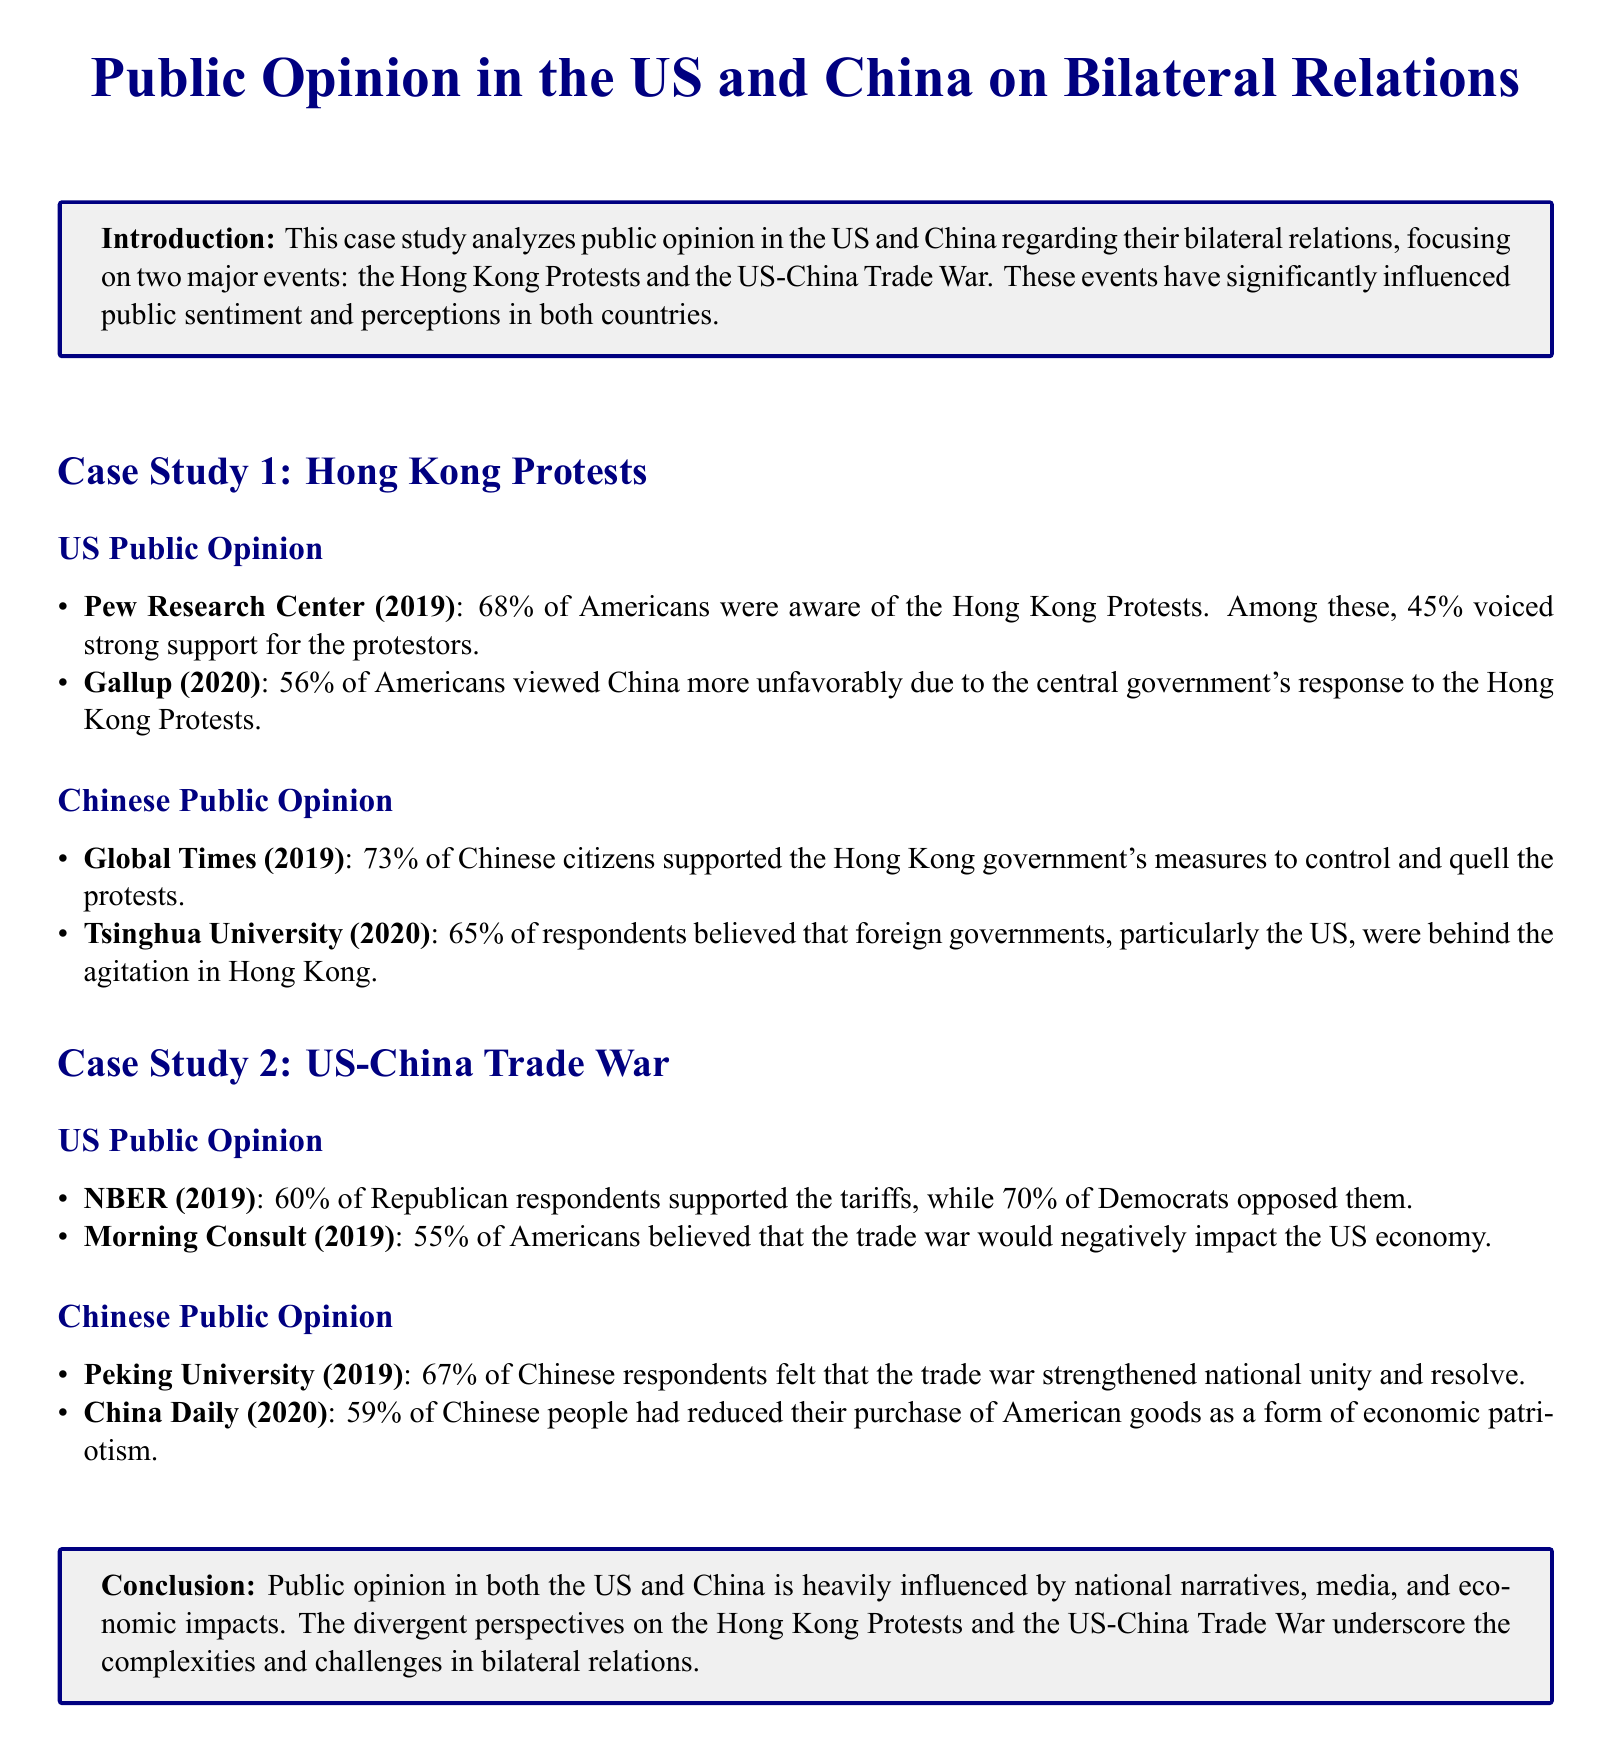What percentage of Americans were aware of the Hong Kong Protests? The document states that 68% of Americans were aware of the Hong Kong Protests according to Pew Research Center.
Answer: 68% What was the strong support percentage for the protestors among aware Americans? According to the same Pew Research Center source, 45% of Americans voiced strong support for the protestors.
Answer: 45% What is the percentage of Chinese citizens who supported the Hong Kong government's measures? The Global Times report indicates that 73% of Chinese citizens supported the Hong Kong government's measures.
Answer: 73% What percentage of Republican respondents supported the tariffs in the US-China Trade War? The NBER survey highlights that 60% of Republican respondents supported the tariffs.
Answer: 60% What was the belief percentage among Americans regarding the negative impact of the trade war on the US economy? The Morning Consult data reveals that 55% of Americans believed that the trade war would negatively impact the US economy.
Answer: 55% What percentage of Chinese respondents felt that the trade war strengthened national unity? According to Peking University, 67% of Chinese respondents felt that the trade war strengthened national unity.
Answer: 67% Which foreign government do 65% of Chinese respondents believe was behind the agitation in Hong Kong? The Tsinghua University survey indicates that 65% of respondents believed the US was behind the agitation in Hong Kong.
Answer: US What is the conclusion about public opinion in both countries based on national narratives? The conclusion mentions that public opinion is influenced by national narratives, media, and economic impacts.
Answer: Influenced by national narratives What event significantly influenced public sentiment in both countries? The document notes that the Hong Kong Protests and the US-China Trade War significantly influenced public sentiment.
Answer: Hong Kong Protests and the US-China Trade War What percentage of Chinese people reduced their purchase of American goods? The China Daily survey reveals that 59% of Chinese people reduced their purchase of American goods as a form of economic patriotism.
Answer: 59% 